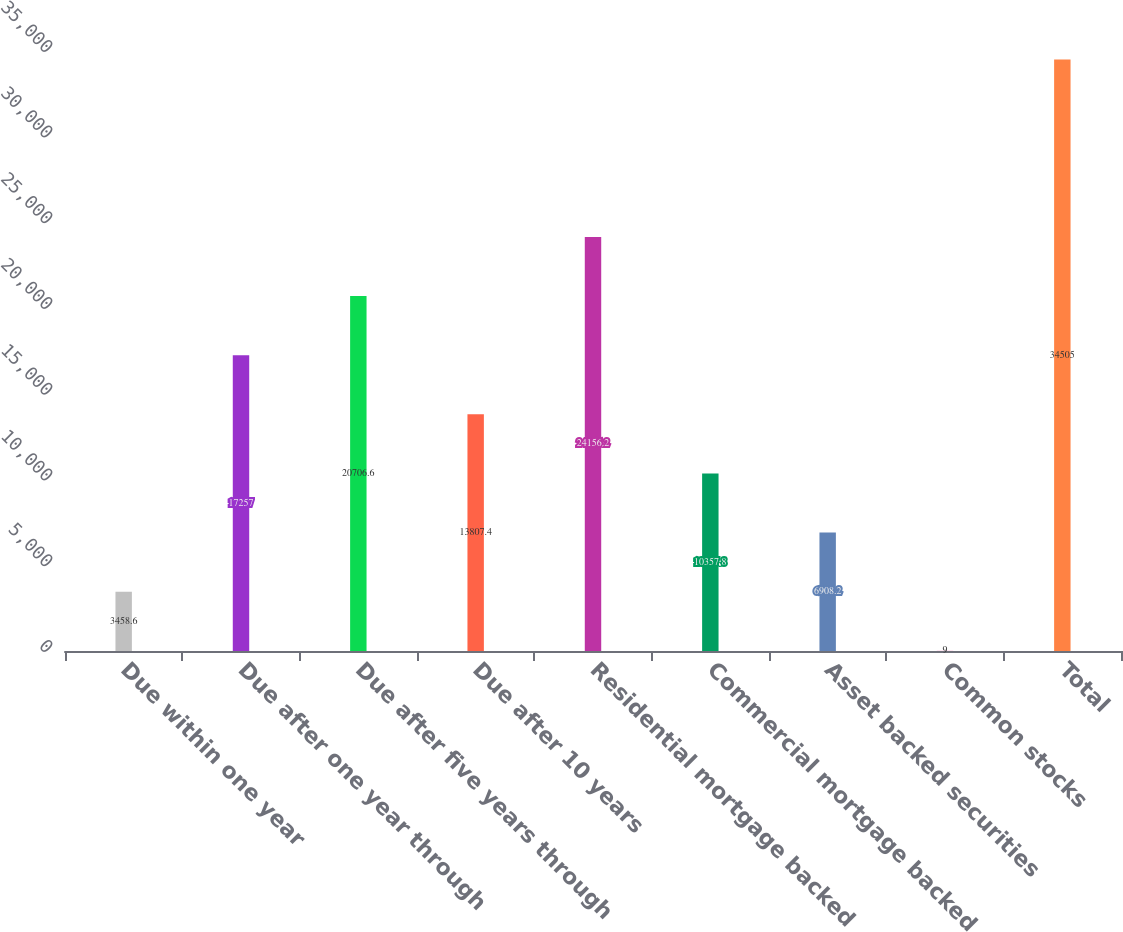<chart> <loc_0><loc_0><loc_500><loc_500><bar_chart><fcel>Due within one year<fcel>Due after one year through<fcel>Due after five years through<fcel>Due after 10 years<fcel>Residential mortgage backed<fcel>Commercial mortgage backed<fcel>Asset backed securities<fcel>Common stocks<fcel>Total<nl><fcel>3458.6<fcel>17257<fcel>20706.6<fcel>13807.4<fcel>24156.2<fcel>10357.8<fcel>6908.2<fcel>9<fcel>34505<nl></chart> 